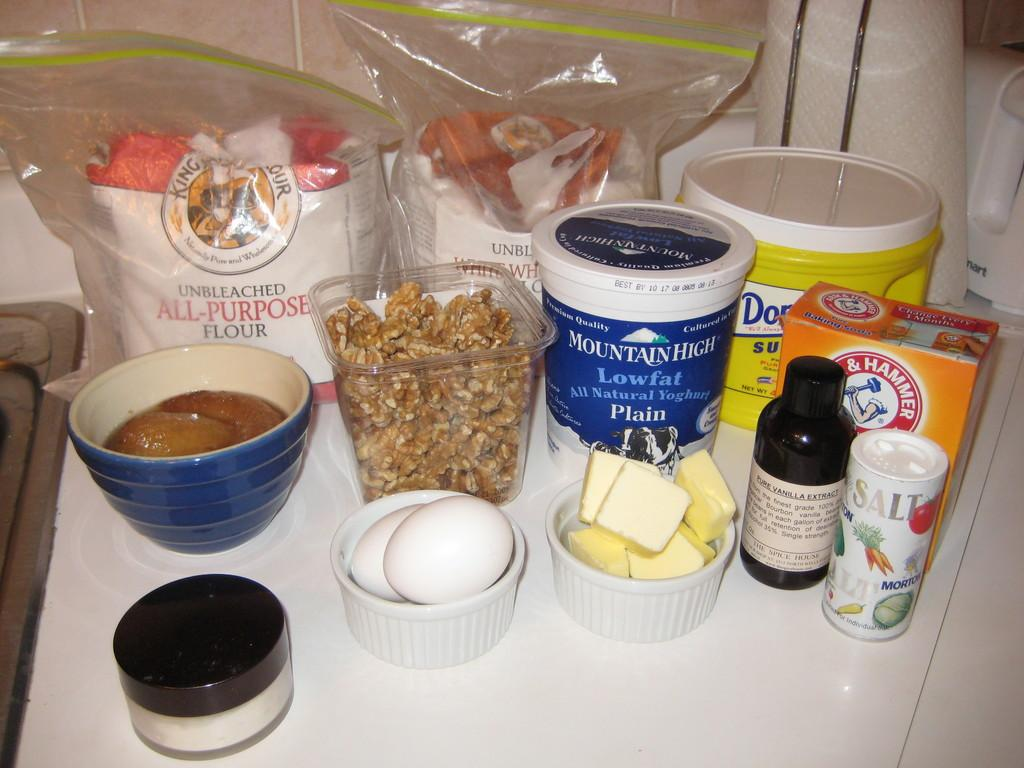<image>
Provide a brief description of the given image. Baking ingredients are assembled on a countertop, including flour and sugar. 